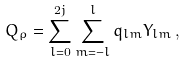<formula> <loc_0><loc_0><loc_500><loc_500>Q _ { \rho } = \sum _ { l = 0 } ^ { 2 j } \sum _ { m = - l } ^ { l } q _ { l m } Y _ { l m } \, ,</formula> 